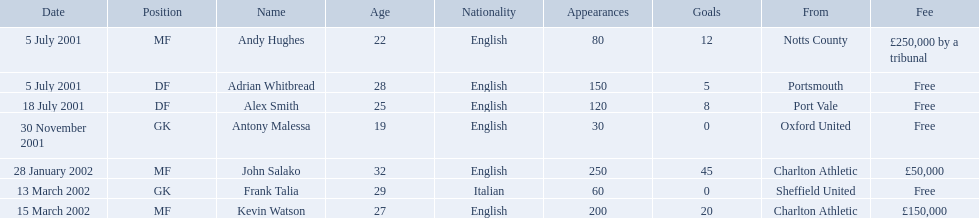What are all of the names? Andy Hughes, Adrian Whitbread, Alex Smith, Antony Malessa, John Salako, Frank Talia, Kevin Watson. What was the fee for each person? £250,000 by a tribunal, Free, Free, Free, £50,000, Free, £150,000. And who had the highest fee? Andy Hughes. 